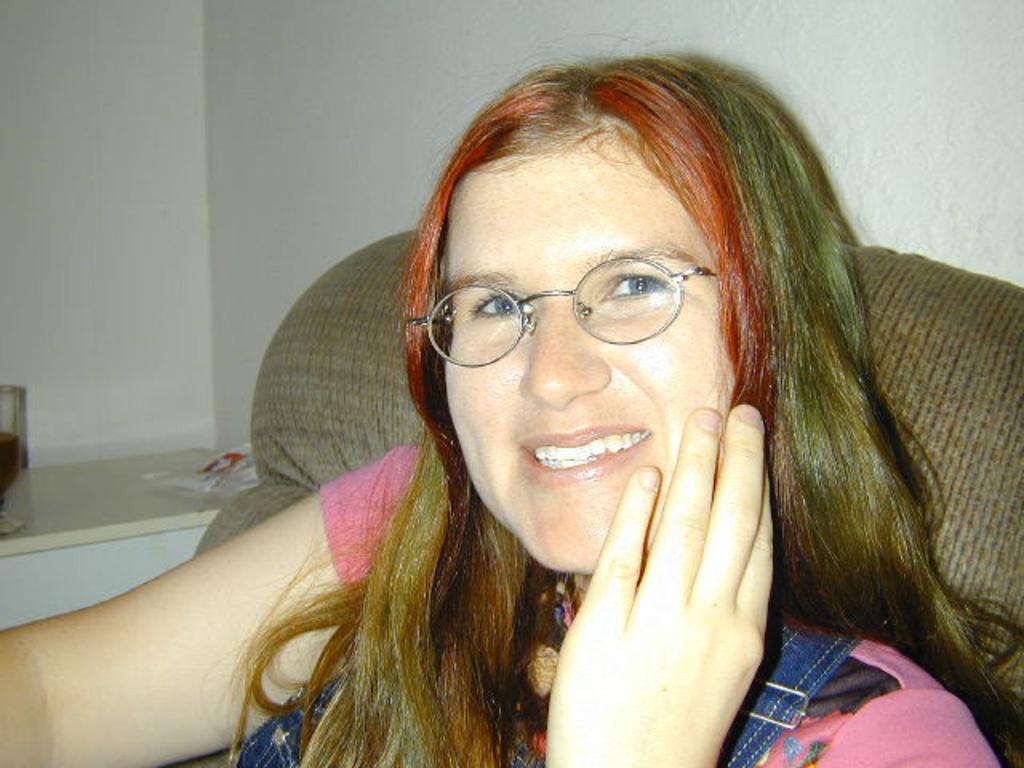Describe this image in one or two sentences. This image consists of a woman. She is wearing specs and a pink color dress. She is sitting on a sofa. There is a glass on the left side. 